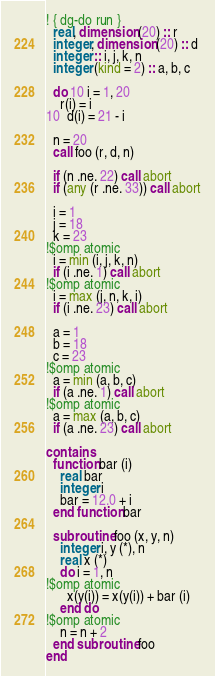Convert code to text. <code><loc_0><loc_0><loc_500><loc_500><_FORTRAN_>! { dg-do run }
  real, dimension (20) :: r
  integer, dimension (20) :: d
  integer :: i, j, k, n
  integer (kind = 2) :: a, b, c

  do 10 i = 1, 20
    r(i) = i
10  d(i) = 21 - i

  n = 20
  call foo (r, d, n)

  if (n .ne. 22) call abort
  if (any (r .ne. 33)) call abort

  i = 1
  j = 18
  k = 23
!$omp atomic
  i = min (i, j, k, n)
  if (i .ne. 1) call abort
!$omp atomic
  i = max (j, n, k, i)
  if (i .ne. 23) call abort

  a = 1
  b = 18
  c = 23
!$omp atomic
  a = min (a, b, c)
  if (a .ne. 1) call abort
!$omp atomic
  a = max (a, b, c)
  if (a .ne. 23) call abort

contains
  function bar (i)
    real bar
    integer i
    bar = 12.0 + i
  end function bar

  subroutine foo (x, y, n)
    integer i, y (*), n
    real x (*)
    do i = 1, n
!$omp atomic
      x(y(i)) = x(y(i)) + bar (i)
    end do
!$omp atomic
    n = n + 2
  end subroutine foo
end
</code> 